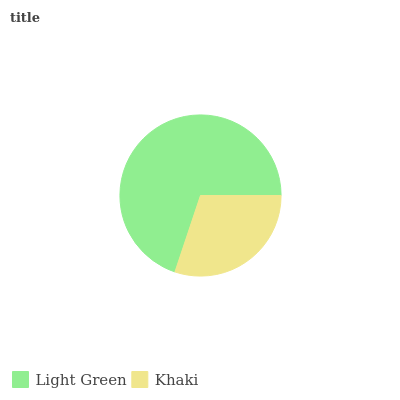Is Khaki the minimum?
Answer yes or no. Yes. Is Light Green the maximum?
Answer yes or no. Yes. Is Khaki the maximum?
Answer yes or no. No. Is Light Green greater than Khaki?
Answer yes or no. Yes. Is Khaki less than Light Green?
Answer yes or no. Yes. Is Khaki greater than Light Green?
Answer yes or no. No. Is Light Green less than Khaki?
Answer yes or no. No. Is Light Green the high median?
Answer yes or no. Yes. Is Khaki the low median?
Answer yes or no. Yes. Is Khaki the high median?
Answer yes or no. No. Is Light Green the low median?
Answer yes or no. No. 